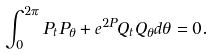<formula> <loc_0><loc_0><loc_500><loc_500>\int _ { 0 } ^ { 2 \pi } P _ { t } P _ { \theta } + e ^ { 2 P } Q _ { t } Q _ { \theta } d \theta = 0 .</formula> 